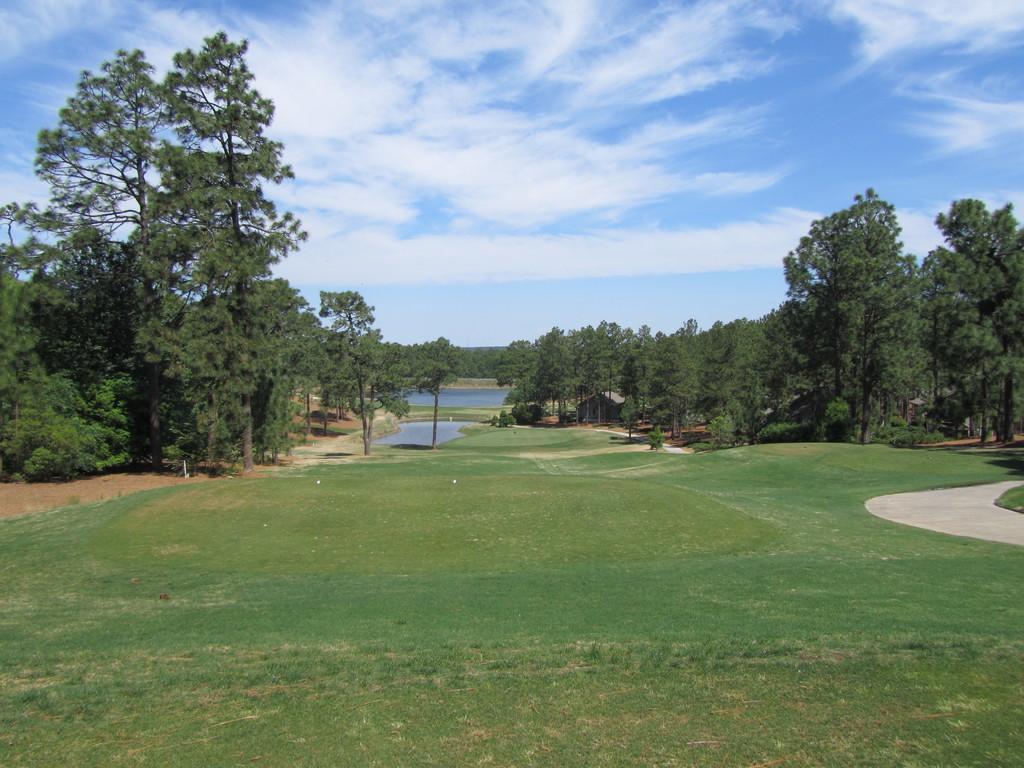What type of vegetation can be seen in the image? There are many trees in the image. What else can be seen besides trees in the image? There is water visible in the image. What is at the bottom of the image? Green grass is present at the bottom of the image. What is visible at the top of the image? The sky is visible at the top of the image. What can be seen in the sky? Clouds are present in the sky. How does the nose of the person in the image start to itch? There is no person present in the image, so it is not possible to determine if anyone's nose is itching or how it might start to itch. 